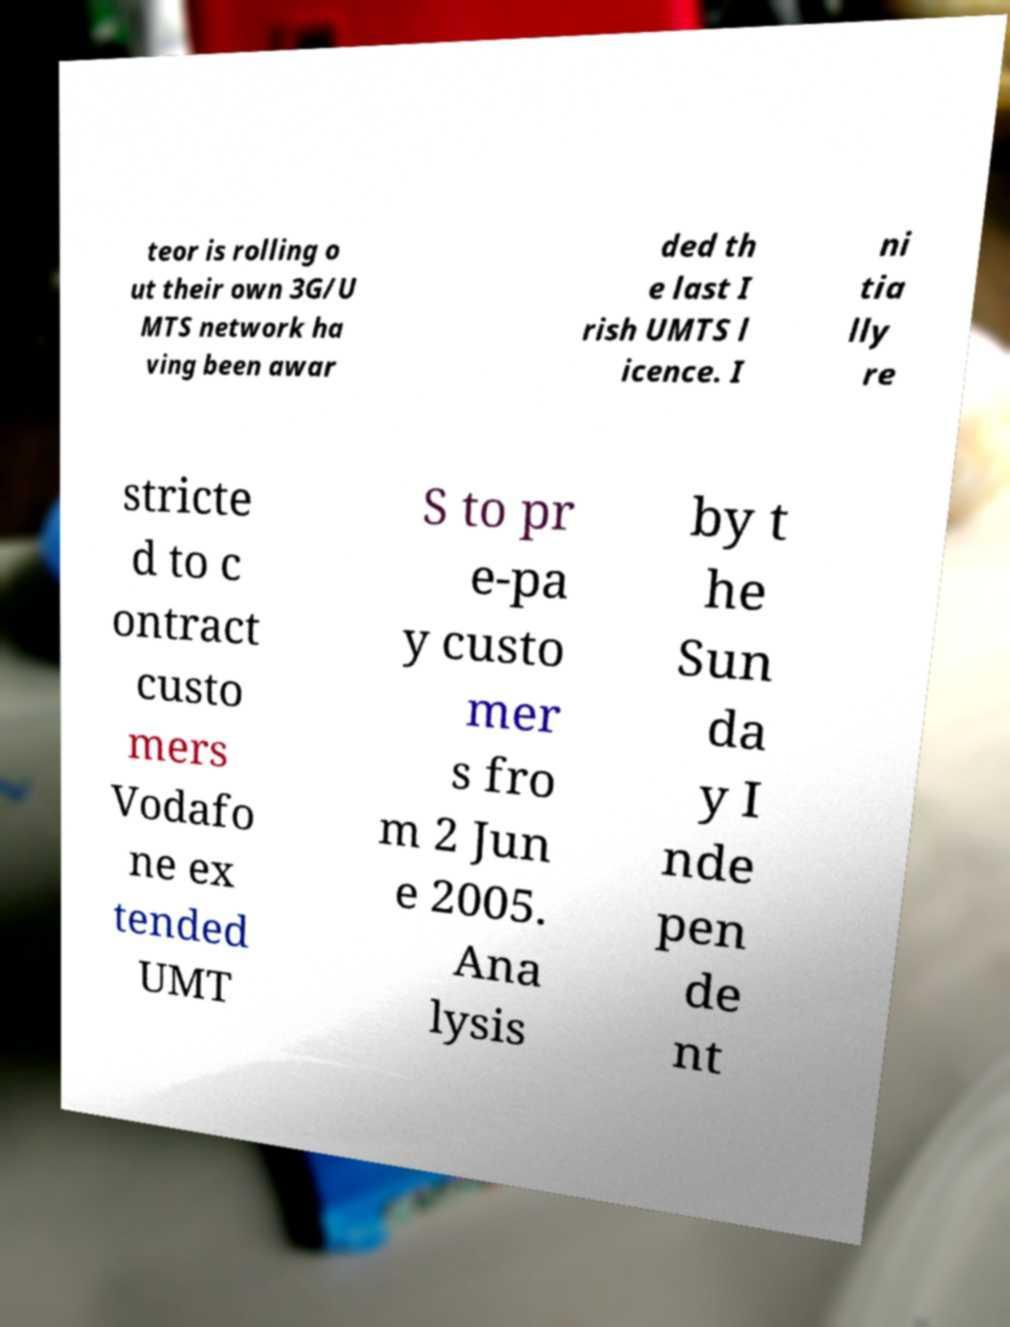Please identify and transcribe the text found in this image. teor is rolling o ut their own 3G/U MTS network ha ving been awar ded th e last I rish UMTS l icence. I ni tia lly re stricte d to c ontract custo mers Vodafo ne ex tended UMT S to pr e-pa y custo mer s fro m 2 Jun e 2005. Ana lysis by t he Sun da y I nde pen de nt 